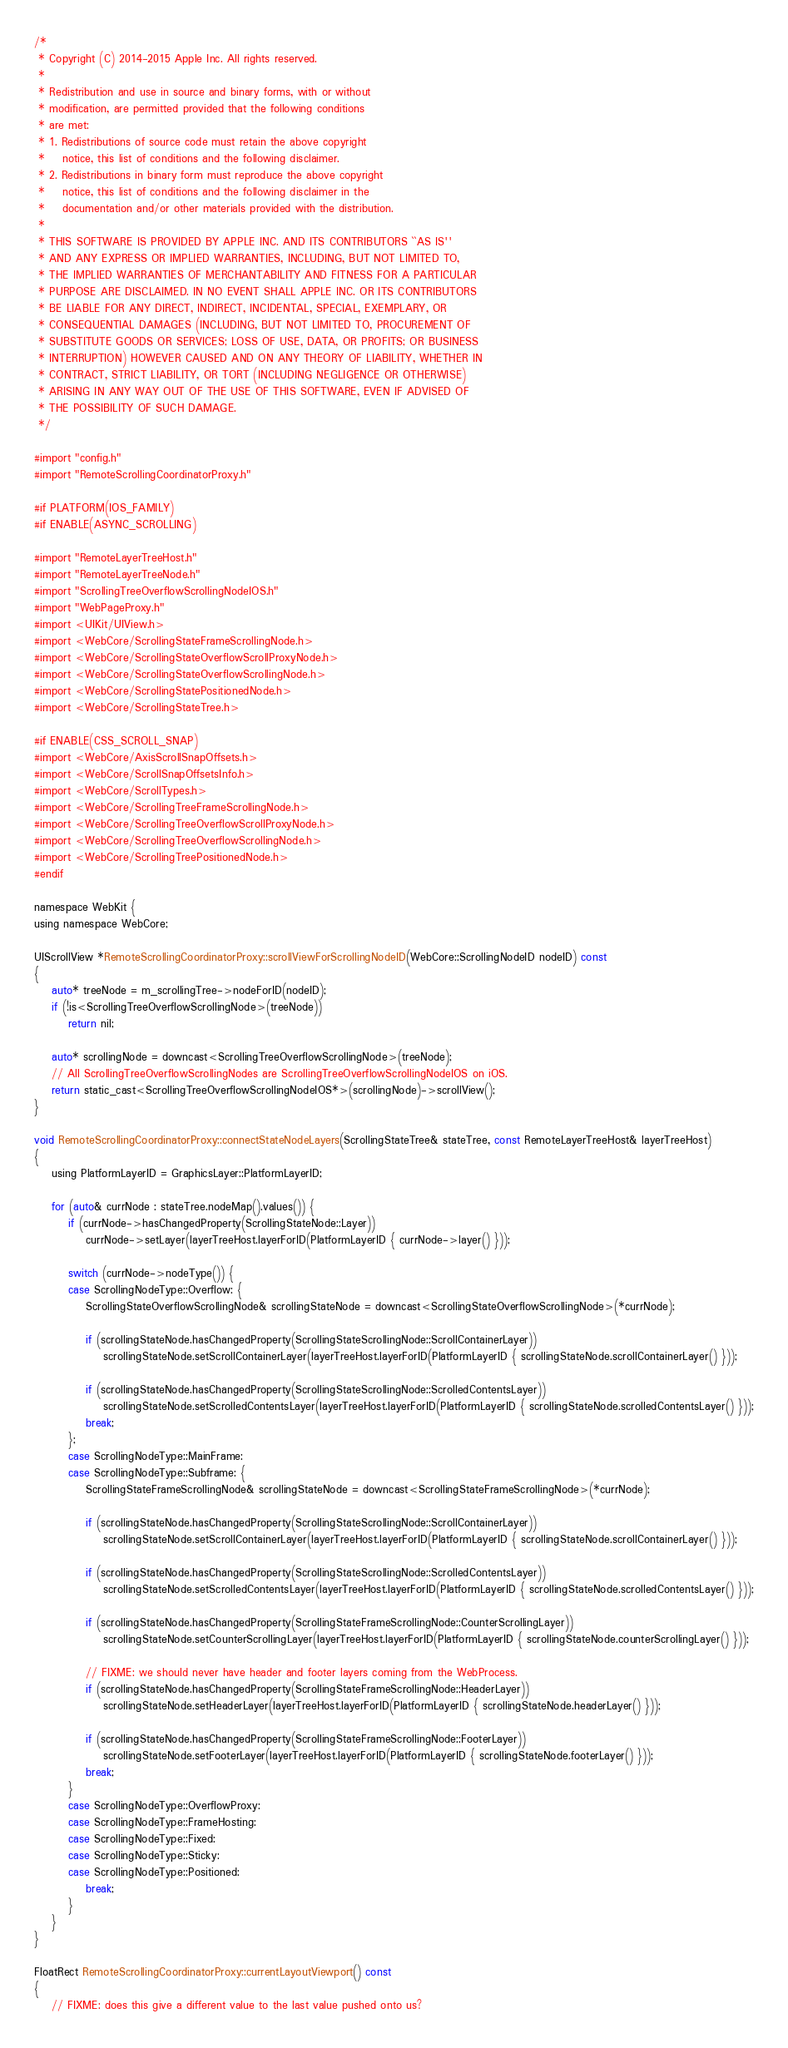<code> <loc_0><loc_0><loc_500><loc_500><_ObjectiveC_>/*
 * Copyright (C) 2014-2015 Apple Inc. All rights reserved.
 *
 * Redistribution and use in source and binary forms, with or without
 * modification, are permitted provided that the following conditions
 * are met:
 * 1. Redistributions of source code must retain the above copyright
 *    notice, this list of conditions and the following disclaimer.
 * 2. Redistributions in binary form must reproduce the above copyright
 *    notice, this list of conditions and the following disclaimer in the
 *    documentation and/or other materials provided with the distribution.
 *
 * THIS SOFTWARE IS PROVIDED BY APPLE INC. AND ITS CONTRIBUTORS ``AS IS''
 * AND ANY EXPRESS OR IMPLIED WARRANTIES, INCLUDING, BUT NOT LIMITED TO,
 * THE IMPLIED WARRANTIES OF MERCHANTABILITY AND FITNESS FOR A PARTICULAR
 * PURPOSE ARE DISCLAIMED. IN NO EVENT SHALL APPLE INC. OR ITS CONTRIBUTORS
 * BE LIABLE FOR ANY DIRECT, INDIRECT, INCIDENTAL, SPECIAL, EXEMPLARY, OR
 * CONSEQUENTIAL DAMAGES (INCLUDING, BUT NOT LIMITED TO, PROCUREMENT OF
 * SUBSTITUTE GOODS OR SERVICES; LOSS OF USE, DATA, OR PROFITS; OR BUSINESS
 * INTERRUPTION) HOWEVER CAUSED AND ON ANY THEORY OF LIABILITY, WHETHER IN
 * CONTRACT, STRICT LIABILITY, OR TORT (INCLUDING NEGLIGENCE OR OTHERWISE)
 * ARISING IN ANY WAY OUT OF THE USE OF THIS SOFTWARE, EVEN IF ADVISED OF
 * THE POSSIBILITY OF SUCH DAMAGE.
 */

#import "config.h"
#import "RemoteScrollingCoordinatorProxy.h"

#if PLATFORM(IOS_FAMILY)
#if ENABLE(ASYNC_SCROLLING)

#import "RemoteLayerTreeHost.h"
#import "RemoteLayerTreeNode.h"
#import "ScrollingTreeOverflowScrollingNodeIOS.h"
#import "WebPageProxy.h"
#import <UIKit/UIView.h>
#import <WebCore/ScrollingStateFrameScrollingNode.h>
#import <WebCore/ScrollingStateOverflowScrollProxyNode.h>
#import <WebCore/ScrollingStateOverflowScrollingNode.h>
#import <WebCore/ScrollingStatePositionedNode.h>
#import <WebCore/ScrollingStateTree.h>

#if ENABLE(CSS_SCROLL_SNAP)
#import <WebCore/AxisScrollSnapOffsets.h>
#import <WebCore/ScrollSnapOffsetsInfo.h>
#import <WebCore/ScrollTypes.h>
#import <WebCore/ScrollingTreeFrameScrollingNode.h>
#import <WebCore/ScrollingTreeOverflowScrollProxyNode.h>
#import <WebCore/ScrollingTreeOverflowScrollingNode.h>
#import <WebCore/ScrollingTreePositionedNode.h>
#endif

namespace WebKit {
using namespace WebCore;

UIScrollView *RemoteScrollingCoordinatorProxy::scrollViewForScrollingNodeID(WebCore::ScrollingNodeID nodeID) const
{
    auto* treeNode = m_scrollingTree->nodeForID(nodeID);
    if (!is<ScrollingTreeOverflowScrollingNode>(treeNode))
        return nil;

    auto* scrollingNode = downcast<ScrollingTreeOverflowScrollingNode>(treeNode);
    // All ScrollingTreeOverflowScrollingNodes are ScrollingTreeOverflowScrollingNodeIOS on iOS.
    return static_cast<ScrollingTreeOverflowScrollingNodeIOS*>(scrollingNode)->scrollView();
}

void RemoteScrollingCoordinatorProxy::connectStateNodeLayers(ScrollingStateTree& stateTree, const RemoteLayerTreeHost& layerTreeHost)
{
    using PlatformLayerID = GraphicsLayer::PlatformLayerID;

    for (auto& currNode : stateTree.nodeMap().values()) {
        if (currNode->hasChangedProperty(ScrollingStateNode::Layer))
            currNode->setLayer(layerTreeHost.layerForID(PlatformLayerID { currNode->layer() }));
        
        switch (currNode->nodeType()) {
        case ScrollingNodeType::Overflow: {
            ScrollingStateOverflowScrollingNode& scrollingStateNode = downcast<ScrollingStateOverflowScrollingNode>(*currNode);

            if (scrollingStateNode.hasChangedProperty(ScrollingStateScrollingNode::ScrollContainerLayer))
                scrollingStateNode.setScrollContainerLayer(layerTreeHost.layerForID(PlatformLayerID { scrollingStateNode.scrollContainerLayer() }));

            if (scrollingStateNode.hasChangedProperty(ScrollingStateScrollingNode::ScrolledContentsLayer))
                scrollingStateNode.setScrolledContentsLayer(layerTreeHost.layerForID(PlatformLayerID { scrollingStateNode.scrolledContentsLayer() }));
            break;
        };
        case ScrollingNodeType::MainFrame:
        case ScrollingNodeType::Subframe: {
            ScrollingStateFrameScrollingNode& scrollingStateNode = downcast<ScrollingStateFrameScrollingNode>(*currNode);

            if (scrollingStateNode.hasChangedProperty(ScrollingStateScrollingNode::ScrollContainerLayer))
                scrollingStateNode.setScrollContainerLayer(layerTreeHost.layerForID(PlatformLayerID { scrollingStateNode.scrollContainerLayer() }));

            if (scrollingStateNode.hasChangedProperty(ScrollingStateScrollingNode::ScrolledContentsLayer))
                scrollingStateNode.setScrolledContentsLayer(layerTreeHost.layerForID(PlatformLayerID { scrollingStateNode.scrolledContentsLayer() }));

            if (scrollingStateNode.hasChangedProperty(ScrollingStateFrameScrollingNode::CounterScrollingLayer))
                scrollingStateNode.setCounterScrollingLayer(layerTreeHost.layerForID(PlatformLayerID { scrollingStateNode.counterScrollingLayer() }));

            // FIXME: we should never have header and footer layers coming from the WebProcess.
            if (scrollingStateNode.hasChangedProperty(ScrollingStateFrameScrollingNode::HeaderLayer))
                scrollingStateNode.setHeaderLayer(layerTreeHost.layerForID(PlatformLayerID { scrollingStateNode.headerLayer() }));

            if (scrollingStateNode.hasChangedProperty(ScrollingStateFrameScrollingNode::FooterLayer))
                scrollingStateNode.setFooterLayer(layerTreeHost.layerForID(PlatformLayerID { scrollingStateNode.footerLayer() }));
            break;
        }
        case ScrollingNodeType::OverflowProxy:
        case ScrollingNodeType::FrameHosting:
        case ScrollingNodeType::Fixed:
        case ScrollingNodeType::Sticky:
        case ScrollingNodeType::Positioned:
            break;
        }
    }
}

FloatRect RemoteScrollingCoordinatorProxy::currentLayoutViewport() const
{
    // FIXME: does this give a different value to the last value pushed onto us?</code> 